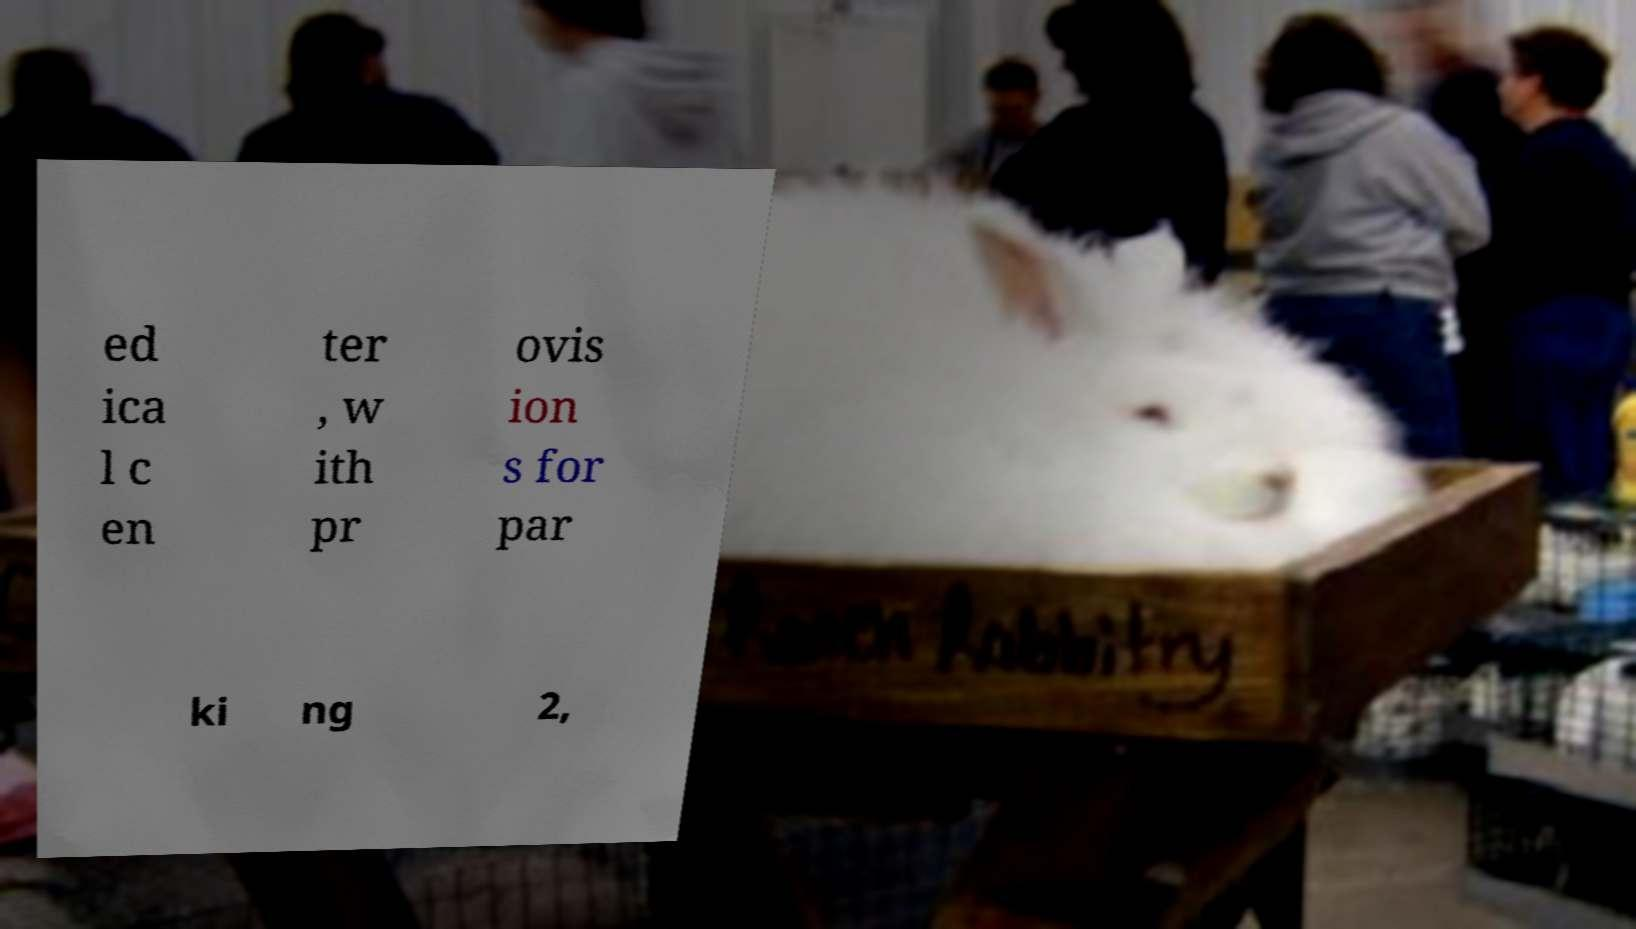Could you assist in decoding the text presented in this image and type it out clearly? ed ica l c en ter , w ith pr ovis ion s for par ki ng 2, 